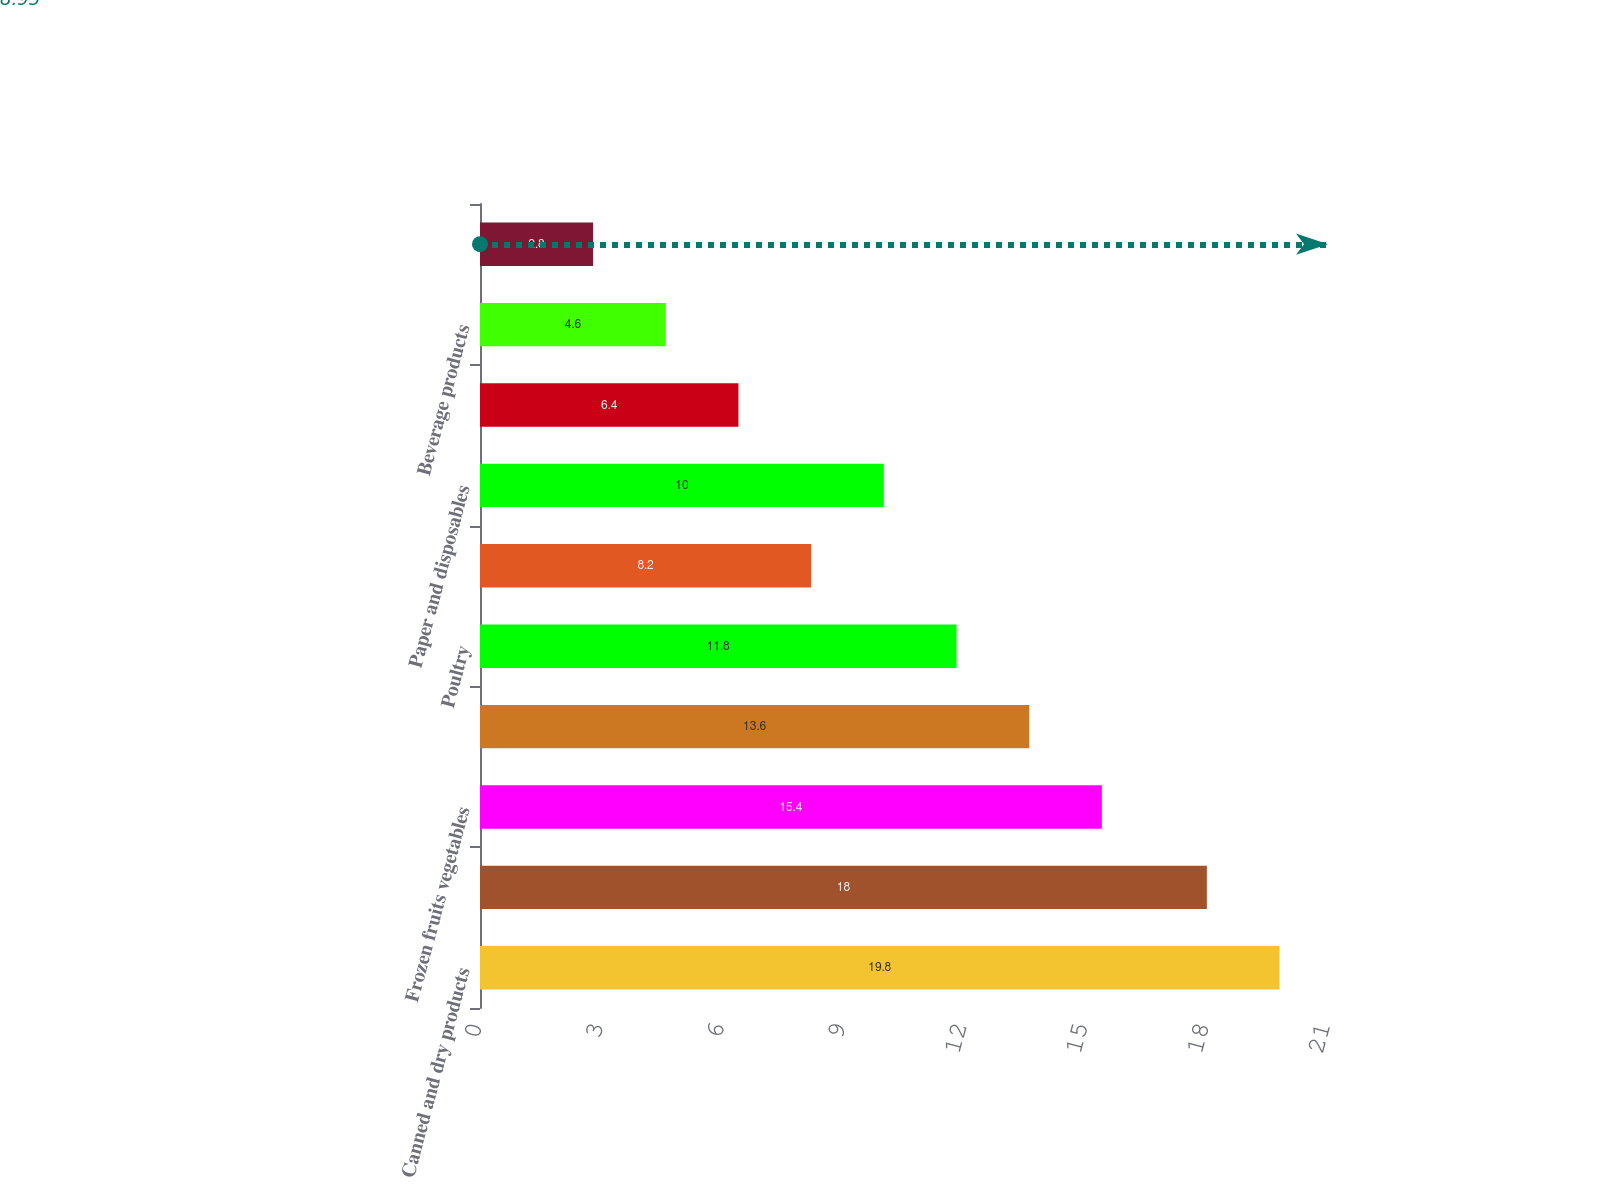<chart> <loc_0><loc_0><loc_500><loc_500><bar_chart><fcel>Canned and dry products<fcel>Fresh and frozen meats<fcel>Frozen fruits vegetables<fcel>Dairy products<fcel>Poultry<fcel>Fresh produce<fcel>Paper and disposables<fcel>Seafood<fcel>Beverage products<fcel>Janitorial products<nl><fcel>19.8<fcel>18<fcel>15.4<fcel>13.6<fcel>11.8<fcel>8.2<fcel>10<fcel>6.4<fcel>4.6<fcel>2.8<nl></chart> 